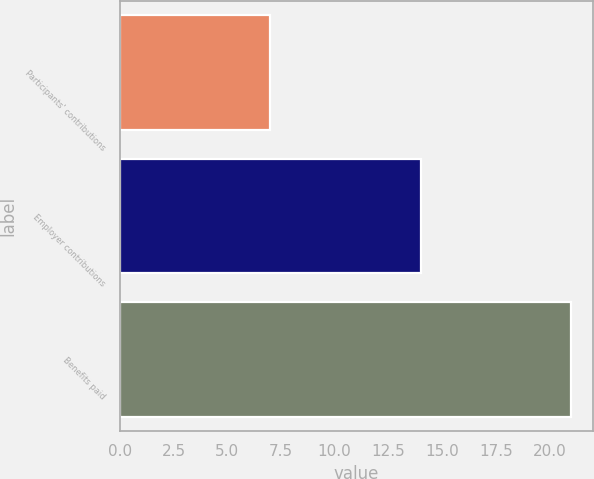Convert chart. <chart><loc_0><loc_0><loc_500><loc_500><bar_chart><fcel>Participants' contributions<fcel>Employer contributions<fcel>Benefits paid<nl><fcel>7<fcel>14<fcel>21<nl></chart> 